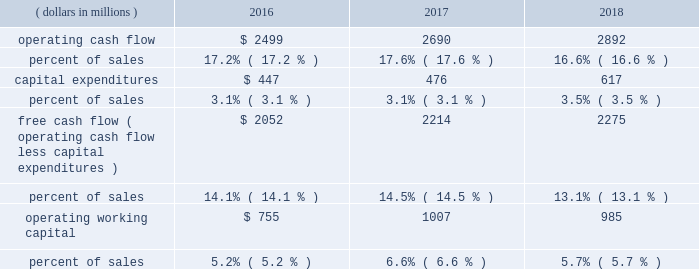24 | 2018 emerson annual report 2017 vs .
2016 2013 commercial & residential solutions sales were $ 5.9 billion in 2017 , an increase of $ 302 million , or 5 percent , reflecting favorable conditions in hvac and refrigeration markets in the u.s. , asia and europe , as well as u.s .
And asian construction markets .
Underlying sales increased 5 percent ( $ 297 million ) on 6 percent higher volume , partially offset by 1 percent lower price .
Foreign currency translation deducted $ 20 million and acquisitions added $ 25 million .
Climate technologies sales were $ 4.2 billion in 2017 , an increase of $ 268 million , or 7 percent .
Global air conditioning sales were solid , led by strength in the u.s .
And asia and robust growth in china partially due to easier comparisons , while sales were up modestly in europe and declined moderately in middle east/africa .
Global refrigeration sales were strong , reflecting robust growth in china on increased adoption of energy- efficient solutions and slight growth in the u.s .
Sensors and solutions had strong growth , while temperature controls was up modestly .
Tools & home products sales were $ 1.6 billion in 2017 , up $ 34 million compared to the prior year .
Professional tools had strong growth on favorable demand from oil and gas customers and in other construction-related markets .
Wet/dry vacuums sales were up moderately as favorable conditions continued in u.s .
Construction markets .
Food waste disposers increased slightly , while the storage business declined moderately .
Overall , underlying sales increased 3 percent in the u.s. , 4 percent in europe and 17 percent in asia ( china up 27 percent ) .
Sales increased 3 percent in latin america and 4 percent in canada , while sales decreased 5 percent in middle east/africa .
Earnings were $ 1.4 billion , an increase of $ 72 million driven by climate technologies , while margin was flat .
Increased volume and resulting leverage , savings from cost reduction actions , and lower customer accommodation costs of $ 16 million were largely offset by higher materials costs , lower price and unfavorable product mix .
Financial position , capital resources and liquidity the company continues to generate substantial cash from operations and has the resources available to reinvest for growth in existing businesses , pursue strategic acquisitions and manage its capital structure on a short- and long-term basis .
Cash flow from continuing operations ( dollars in millions ) 2016 2017 2018 .
Operating cash flow from continuing operations for 2018 was $ 2.9 billion , a $ 202 million , or 8 percent increase compared with 2017 , primarily due to higher earnings , partially offset by an increase in working capital investment to support higher levels of sales activity and income taxes paid on the residential storage divestiture .
Operating cash flow from continuing operations of $ 2.7 billion in 2017 increased 8 percent compared to $ 2.5 billion in 2016 , reflecting higher earnings and favorable changes in working capital .
At september 30 , 2018 , operating working capital as a percent of sales was 5.7 percent compared with 6.6 percent in 2017 and 5.2 percent in 2016 .
The increase in 2017 was due to higher levels of working capital in the acquired valves & controls business .
Operating cash flow from continuing operations funded capital expenditures of $ 617 million , dividends of $ 1.2 billion , and common stock purchases of $ 1.0 billion .
In 2018 , the company repatriated $ 1.4 billion of cash held by non-u.s .
Subsidiaries , which was part of the company 2019s previously announced plans .
These funds along with increased short-term borrowings and divestiture proceeds supported acquisitions of $ 2.2 billion .
Contributions to pension plans were $ 61 million in 2018 , $ 45 million in 2017 and $ 66 million in 2016 .
Capital expenditures related to continuing operations were $ 617 million , $ 476 million and $ 447 million in 2018 , 2017 and 2016 , respectively .
Free cash flow from continuing operations ( operating cash flow less capital expenditures ) was $ 2.3 billion in 2018 , up 3 percent .
Free cash flow was $ 2.2 billion in 2017 , compared with $ 2.1 billion in 2016 .
The company is targeting capital spending of approximately $ 650 million in 2019 .
Net cash paid in connection with acquisitions was $ 2.2 billion , $ 3.0 billion and $ 132 million in 2018 , 2017 and 2016 , respectively .
Proceeds from divestitures not classified as discontinued operations were $ 201 million and $ 39 million in 2018 and 2017 , respectively .
Dividends were $ 1.2 billion ( $ 1.94 per share ) in 2018 , compared with $ 1.2 billion ( $ 1.92 per share ) in 2017 and $ 1.2 billion ( $ 1.90 per share ) in 2016 .
In november 2018 , the board of directors voted to increase the quarterly cash dividend 1 percent , to an annualized rate of $ 1.96 per share .
Purchases of emerson common stock totaled $ 1.0 billion , $ 400 million and $ 601 million in 2018 , 2017 and 2016 , respectively , at average per share prices of $ 66.25 , $ 60.51 and $ 48.11 .
The board of directors authorized the purchase of up to 70 million common shares in november 2015 , and 41.8 million shares remain available for purchase under this authorization .
The company purchased 15.1 million shares in 2018 , 6.6 million shares in 2017 , and 12.5 million shares in 2016 under this authorization and the remainder of the may 2013 authorization. .
What was the percentage change in capital expenditures between 2017 and 2018? 
Computations: ((617 - 476) / 476)
Answer: 0.29622. 